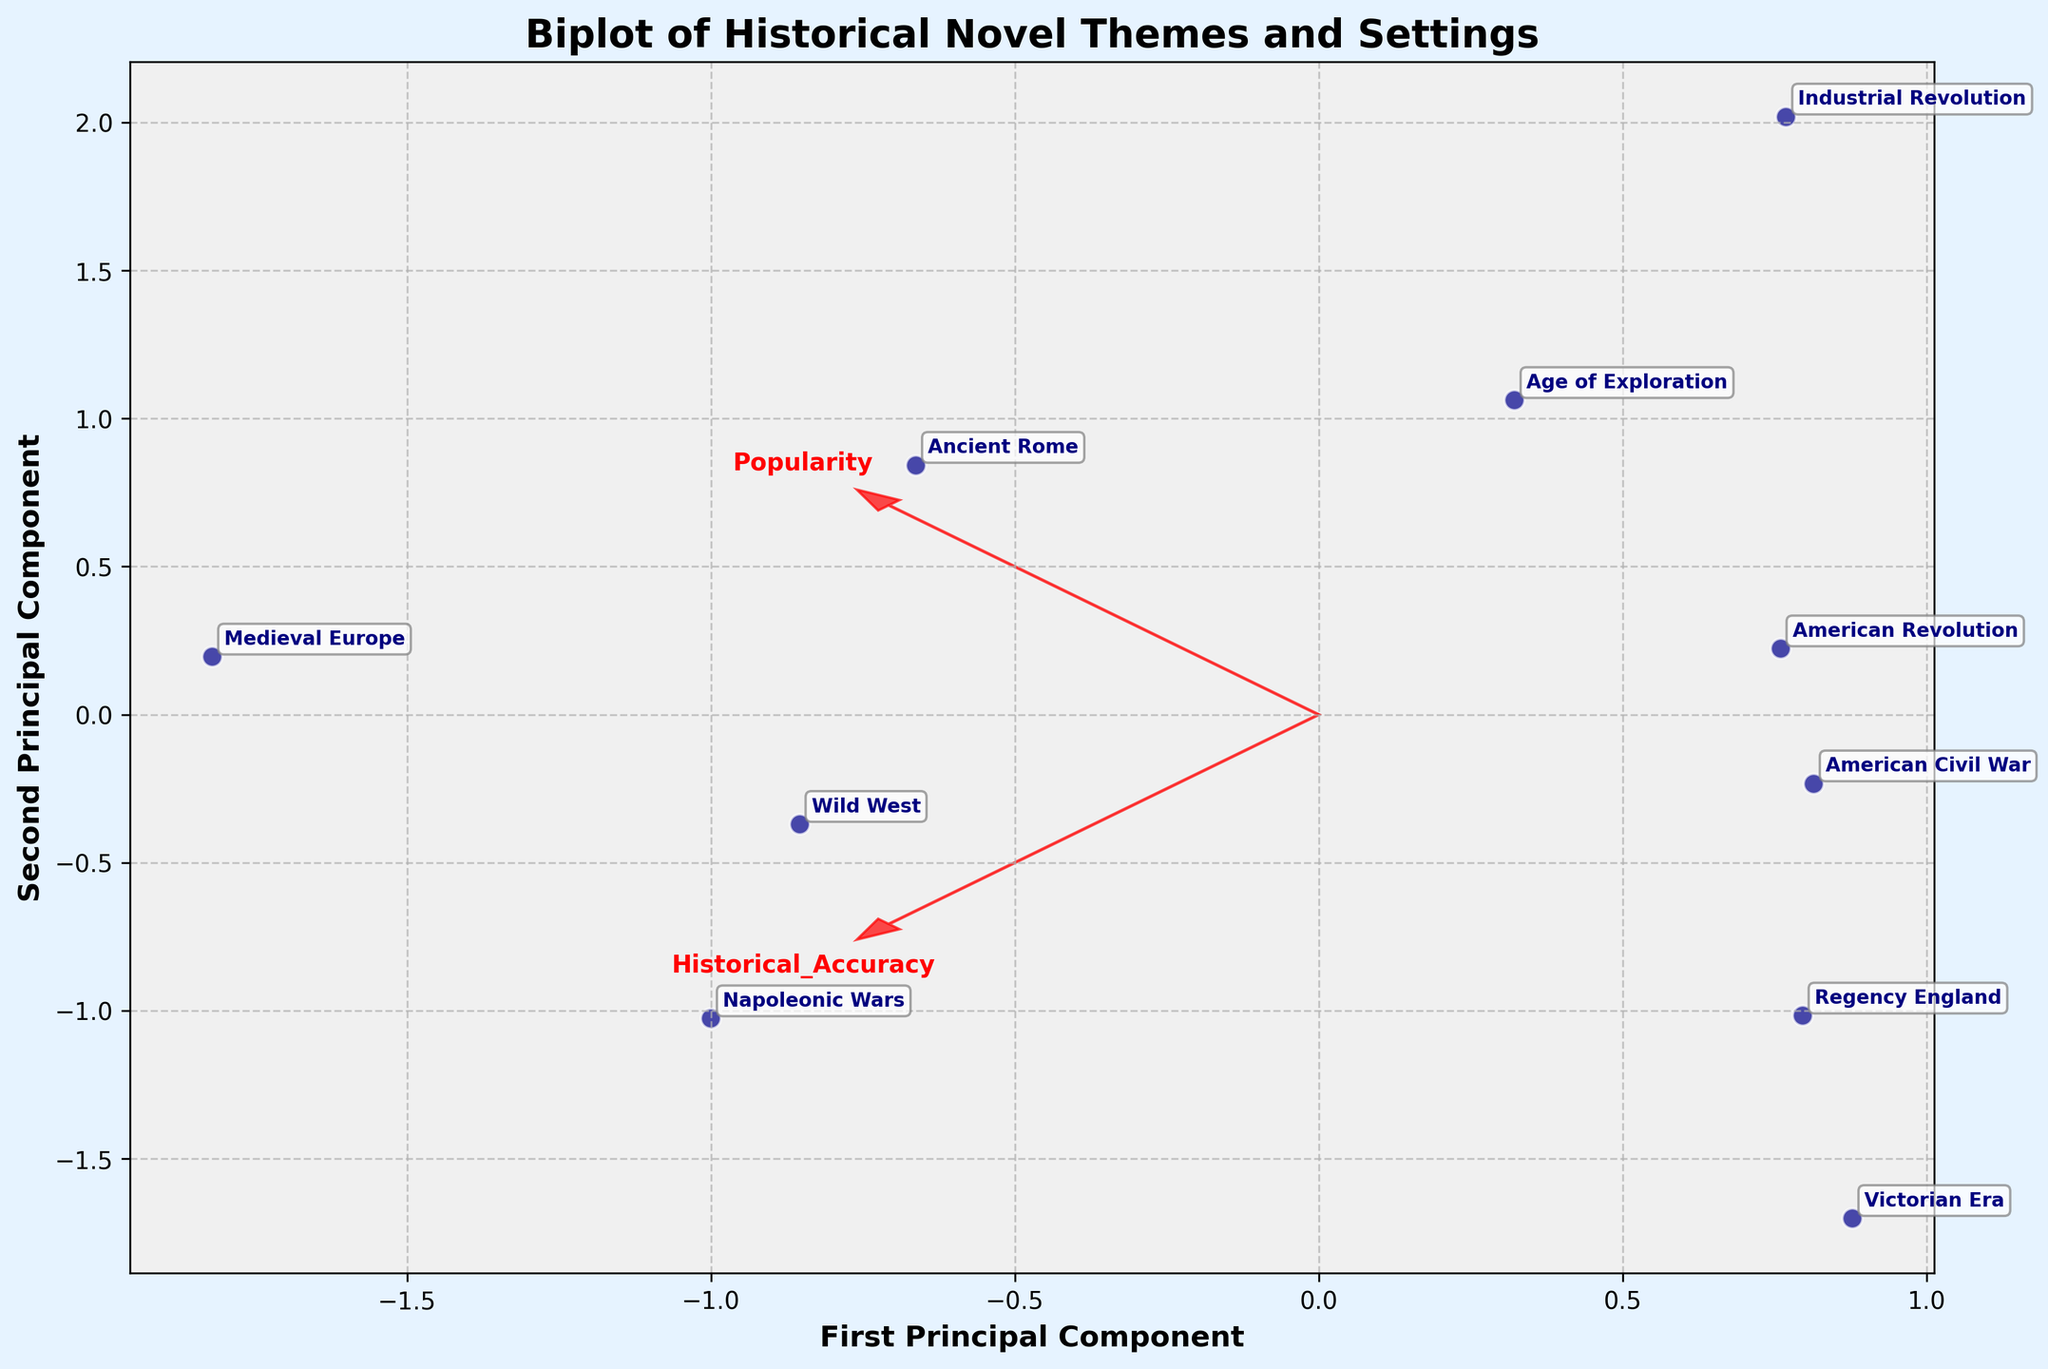How many themes are depicted in the biplot? By counting the number of unique data points labeled with text, we can identify that there are 10 distinct themes represented in the biplot.
Answer: 10 Which theme appears closest to the origin of the biplot? By examining the plotted points relative to the origin (0,0), "American Revolution" appears to be the closest theme.
Answer: American Revolution Between "Victorian Era" and "Industrial Revolution," which theme has higher historical accuracy? By comparing their positions in the biplot, where the y-axis represents historical accuracy, "Victorian Era" is positioned higher than "Industrial Revolution," indicating it has higher historical accuracy.
Answer: Victorian Era What is the approximate angle between the principal component vectors for popularity and historical accuracy? The principal component vectors are plotted as arrows from the origin. By estimating the angle between them, it appears to be approximately 90 degrees, indicating orthogonality.
Answer: 90 degrees How does the theme "Regency England" compare in popularity to "Ancient Rome"? By comparing their relative positions along the x-axis, which represents popularity, "Regency England" is positioned further to the right than "Ancient Rome," indicating higher popularity.
Answer: Regency England Which principal component (first or second) has a higher influence on historical accuracy? The principal component vectors indicate the direction of influence on the variables. The second principal component (y-axis) aligns more closely with historical accuracy, signifying a higher influence.
Answer: Second principal component For which theme is the difference in popularity and historical accuracy the greatest? By observing the relative positions along the x and y axes, "Medieval Europe" shows a noticeable discrepancy between its higher popularity and lower historical accuracy.
Answer: Medieval Europe Which theme related to equestrian sports is plotted higher along the historical accuracy axis? Themes like "Victorian Era" (horse racing) and "Industrial Revolution" (equestrian sports) are involved. Among these, "Victorian Era" is plotted higher along the historical accuracy axis.
Answer: Victorian Era Which two themes are most similar in terms of both popularity and historical accuracy? By examining the proximity of data points in the biplot, "American Civil War" and "American Revolution" appear closest together, indicating similarity in both metrics.
Answer: American Civil War and American Revolution 